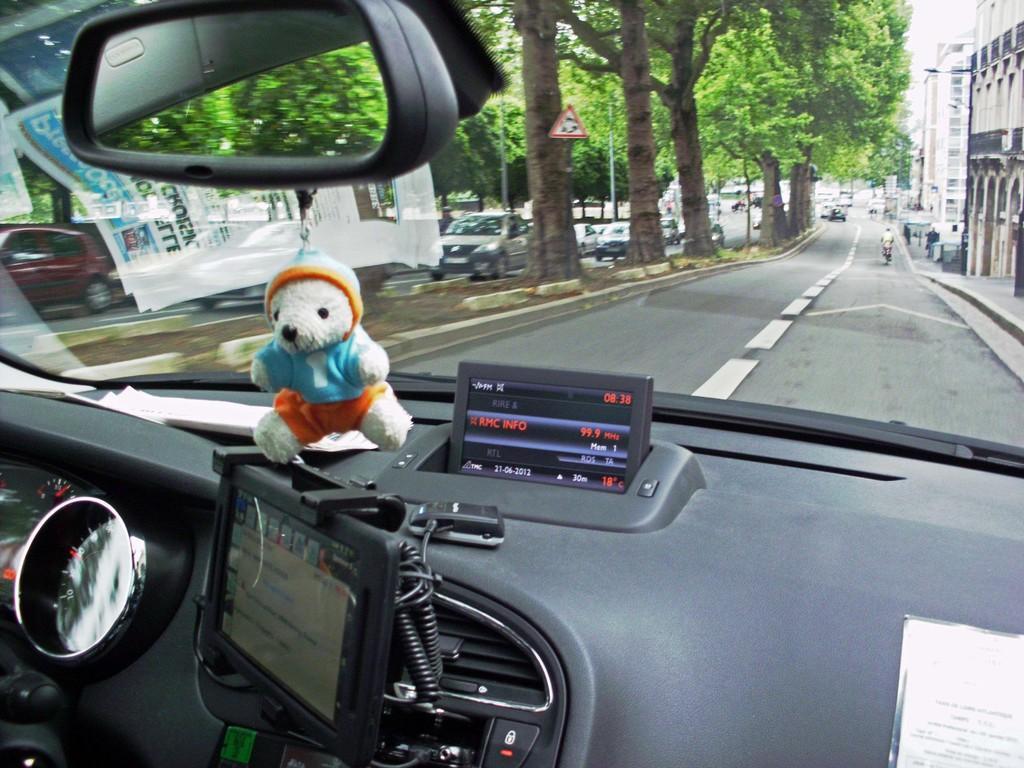How would you summarize this image in a sentence or two? The picture is taken inside a vehicle. On the vehicle there are screens, meters, a mirror on the top. A toy is hanging. Through the glass we can see outside few vehicles are moving on the road, trees, sign boards, pole. In the top right there are buildings. 